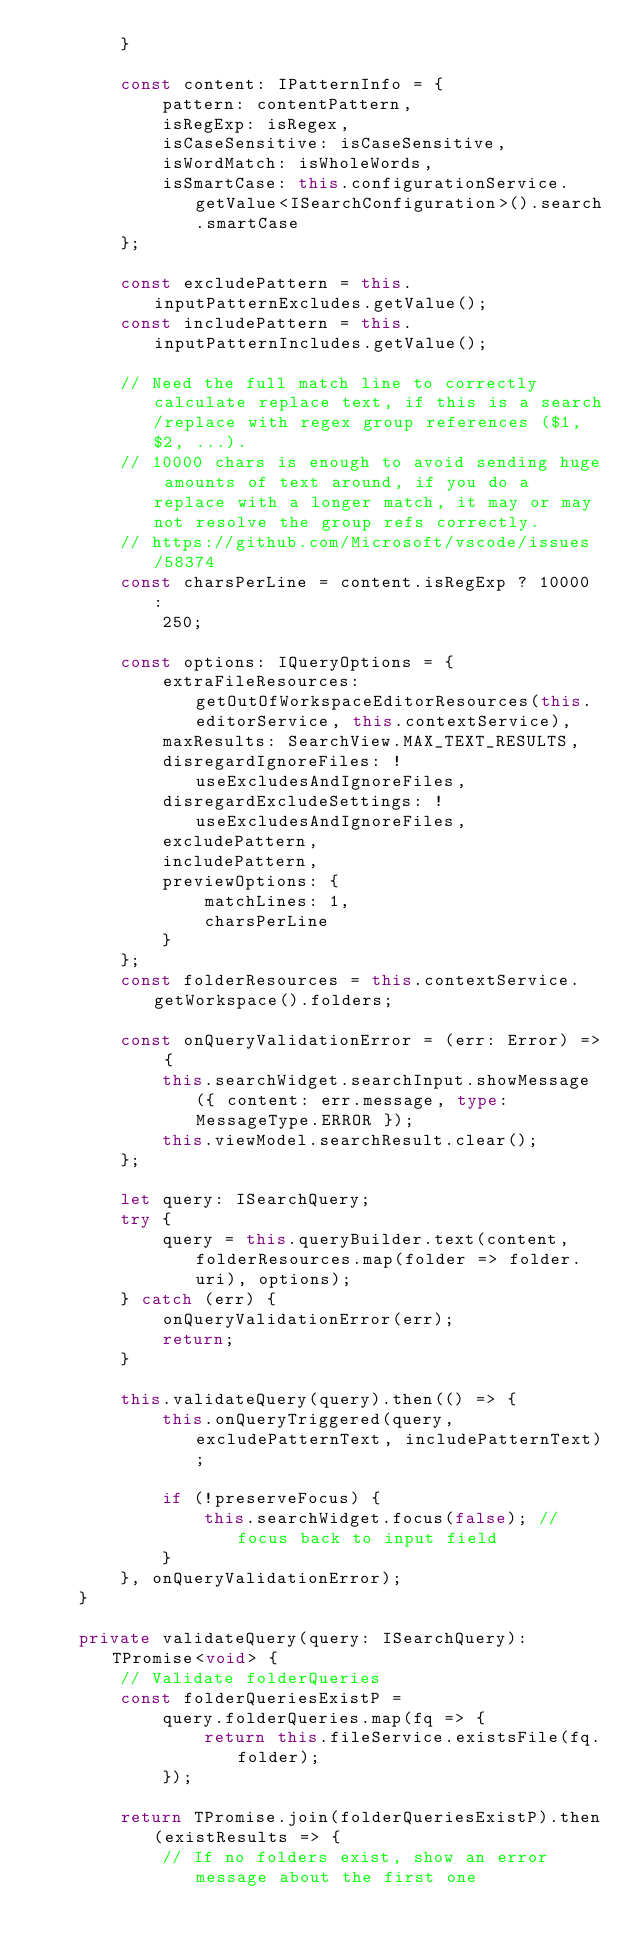Convert code to text. <code><loc_0><loc_0><loc_500><loc_500><_TypeScript_>		}

		const content: IPatternInfo = {
			pattern: contentPattern,
			isRegExp: isRegex,
			isCaseSensitive: isCaseSensitive,
			isWordMatch: isWholeWords,
			isSmartCase: this.configurationService.getValue<ISearchConfiguration>().search.smartCase
		};

		const excludePattern = this.inputPatternExcludes.getValue();
		const includePattern = this.inputPatternIncludes.getValue();

		// Need the full match line to correctly calculate replace text, if this is a search/replace with regex group references ($1, $2, ...).
		// 10000 chars is enough to avoid sending huge amounts of text around, if you do a replace with a longer match, it may or may not resolve the group refs correctly.
		// https://github.com/Microsoft/vscode/issues/58374
		const charsPerLine = content.isRegExp ? 10000 :
			250;

		const options: IQueryOptions = {
			extraFileResources: getOutOfWorkspaceEditorResources(this.editorService, this.contextService),
			maxResults: SearchView.MAX_TEXT_RESULTS,
			disregardIgnoreFiles: !useExcludesAndIgnoreFiles,
			disregardExcludeSettings: !useExcludesAndIgnoreFiles,
			excludePattern,
			includePattern,
			previewOptions: {
				matchLines: 1,
				charsPerLine
			}
		};
		const folderResources = this.contextService.getWorkspace().folders;

		const onQueryValidationError = (err: Error) => {
			this.searchWidget.searchInput.showMessage({ content: err.message, type: MessageType.ERROR });
			this.viewModel.searchResult.clear();
		};

		let query: ISearchQuery;
		try {
			query = this.queryBuilder.text(content, folderResources.map(folder => folder.uri), options);
		} catch (err) {
			onQueryValidationError(err);
			return;
		}

		this.validateQuery(query).then(() => {
			this.onQueryTriggered(query, excludePatternText, includePatternText);

			if (!preserveFocus) {
				this.searchWidget.focus(false); // focus back to input field
			}
		}, onQueryValidationError);
	}

	private validateQuery(query: ISearchQuery): TPromise<void> {
		// Validate folderQueries
		const folderQueriesExistP =
			query.folderQueries.map(fq => {
				return this.fileService.existsFile(fq.folder);
			});

		return TPromise.join(folderQueriesExistP).then(existResults => {
			// If no folders exist, show an error message about the first one</code> 